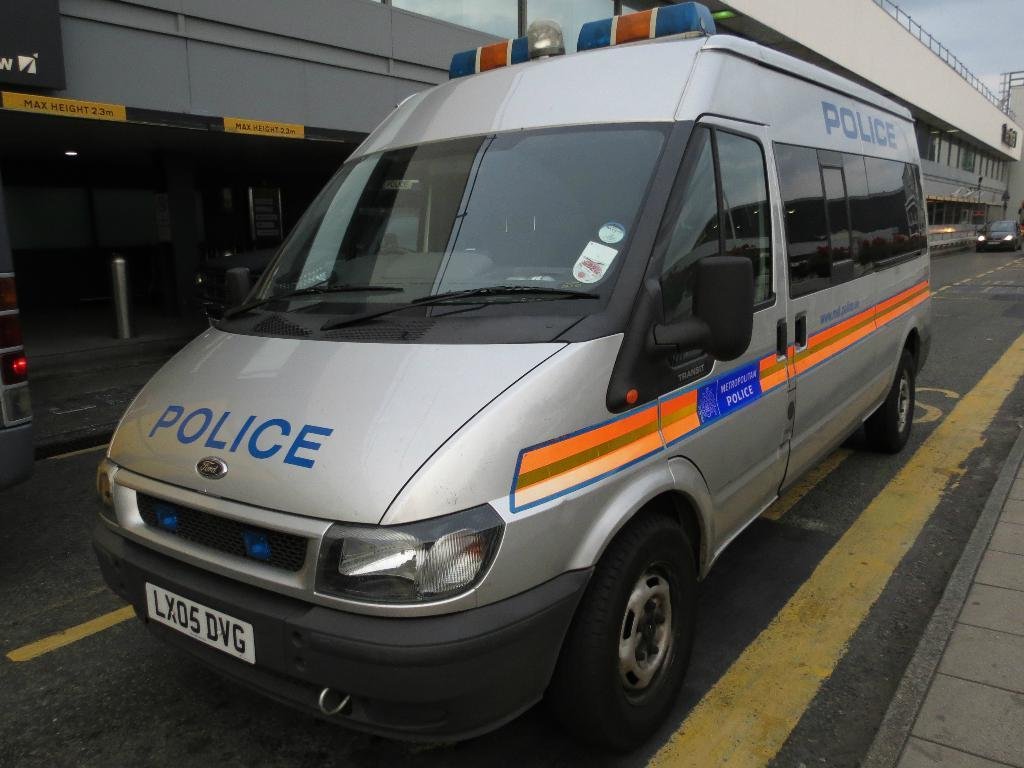<image>
Render a clear and concise summary of the photo. Silver and black van which has the word POLICE on the hood. 